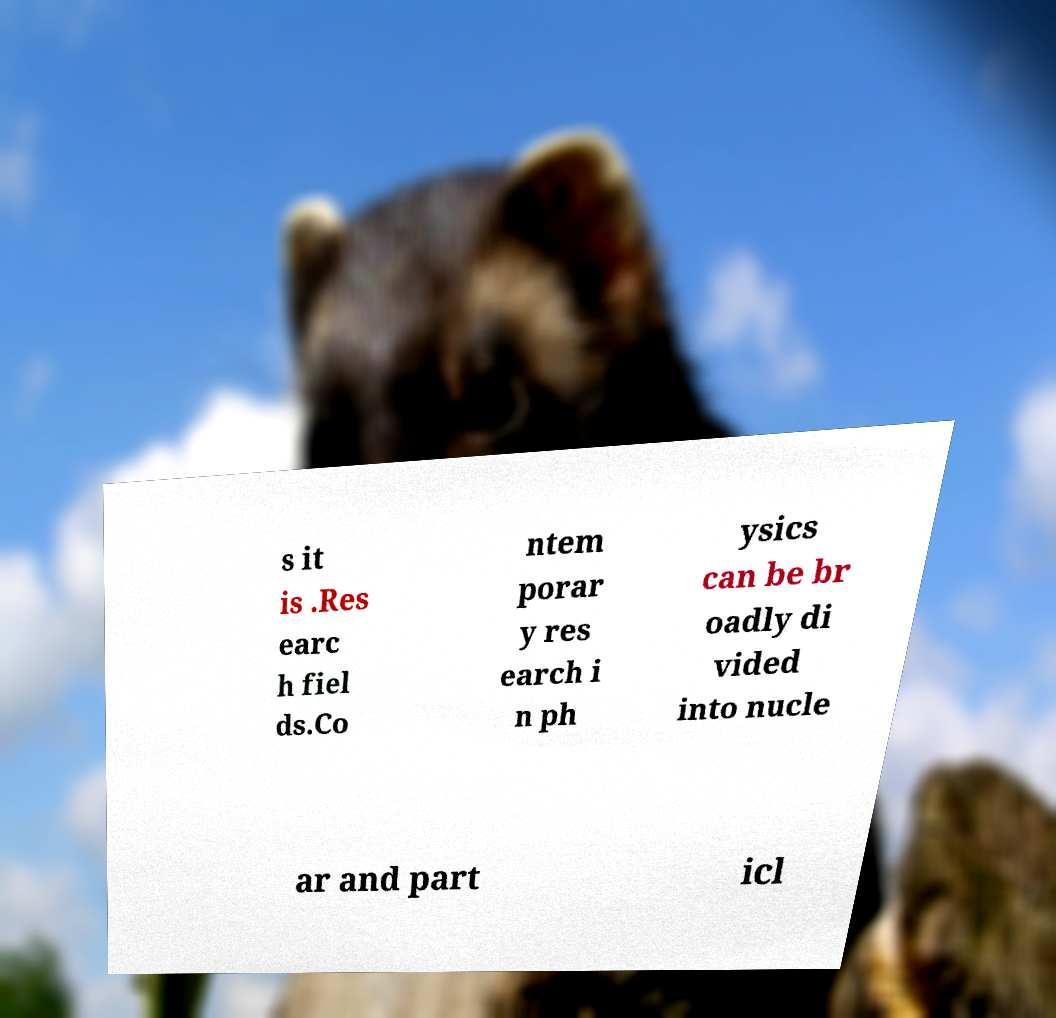Please read and relay the text visible in this image. What does it say? s it is .Res earc h fiel ds.Co ntem porar y res earch i n ph ysics can be br oadly di vided into nucle ar and part icl 